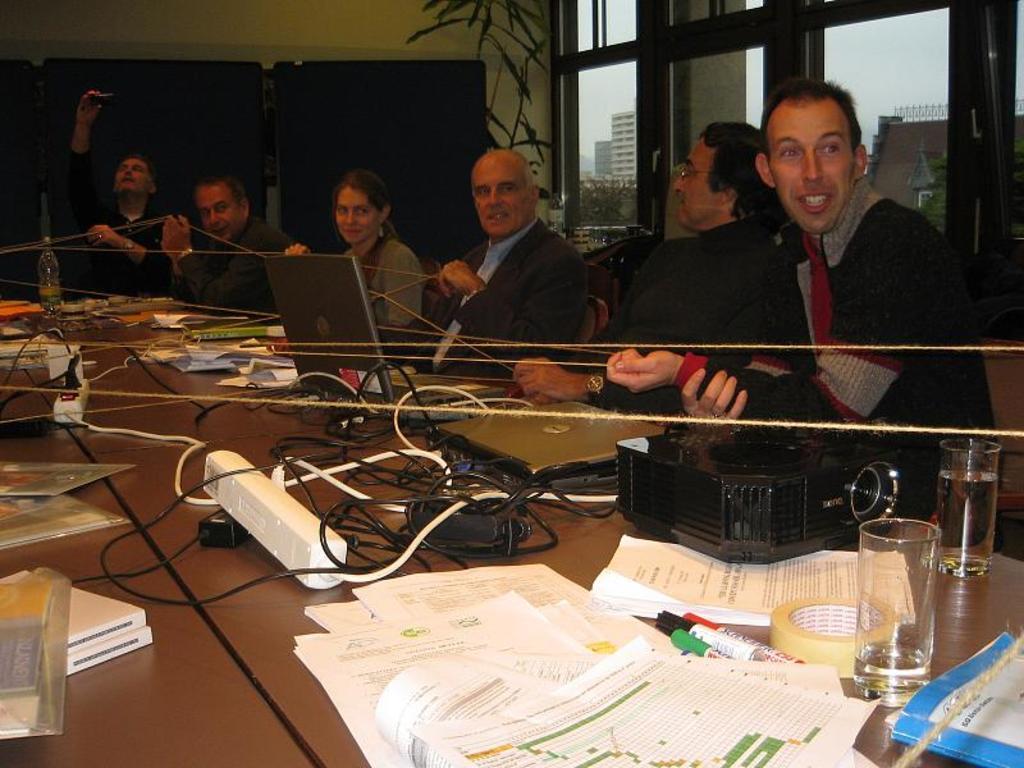Could you give a brief overview of what you see in this image? This is the picture of a room. In this image there are group of people sitting. There are laptops, wires, papers, glasses and there is a bottle, projector on the table. At the back there is a plant. There is a building and sky behind the door. 